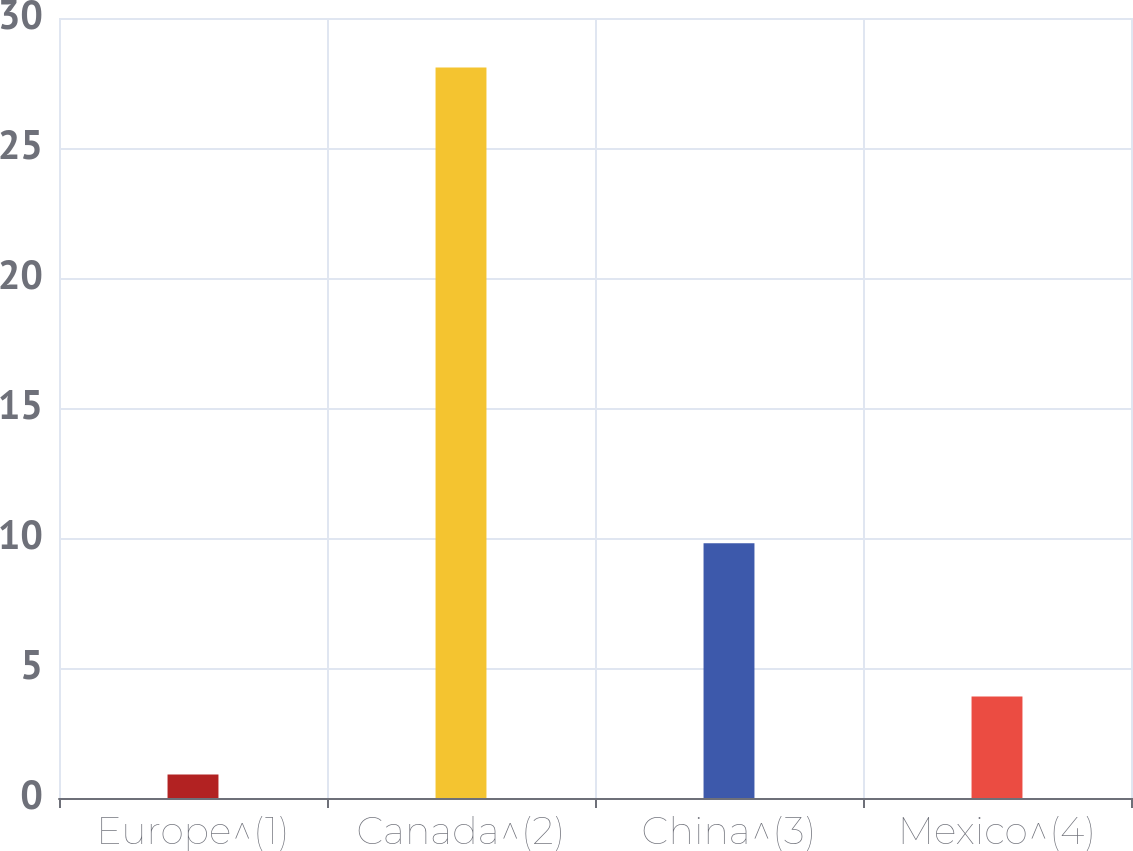Convert chart to OTSL. <chart><loc_0><loc_0><loc_500><loc_500><bar_chart><fcel>Europe^(1)<fcel>Canada^(2)<fcel>China^(3)<fcel>Mexico^(4)<nl><fcel>0.9<fcel>28.1<fcel>9.8<fcel>3.9<nl></chart> 